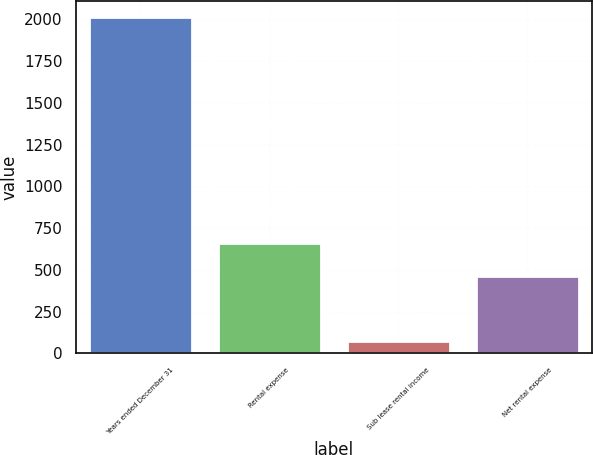Convert chart. <chart><loc_0><loc_0><loc_500><loc_500><bar_chart><fcel>Years ended December 31<fcel>Rental expense<fcel>Sub lease rental income<fcel>Net rental expense<nl><fcel>2012<fcel>658<fcel>72<fcel>464<nl></chart> 